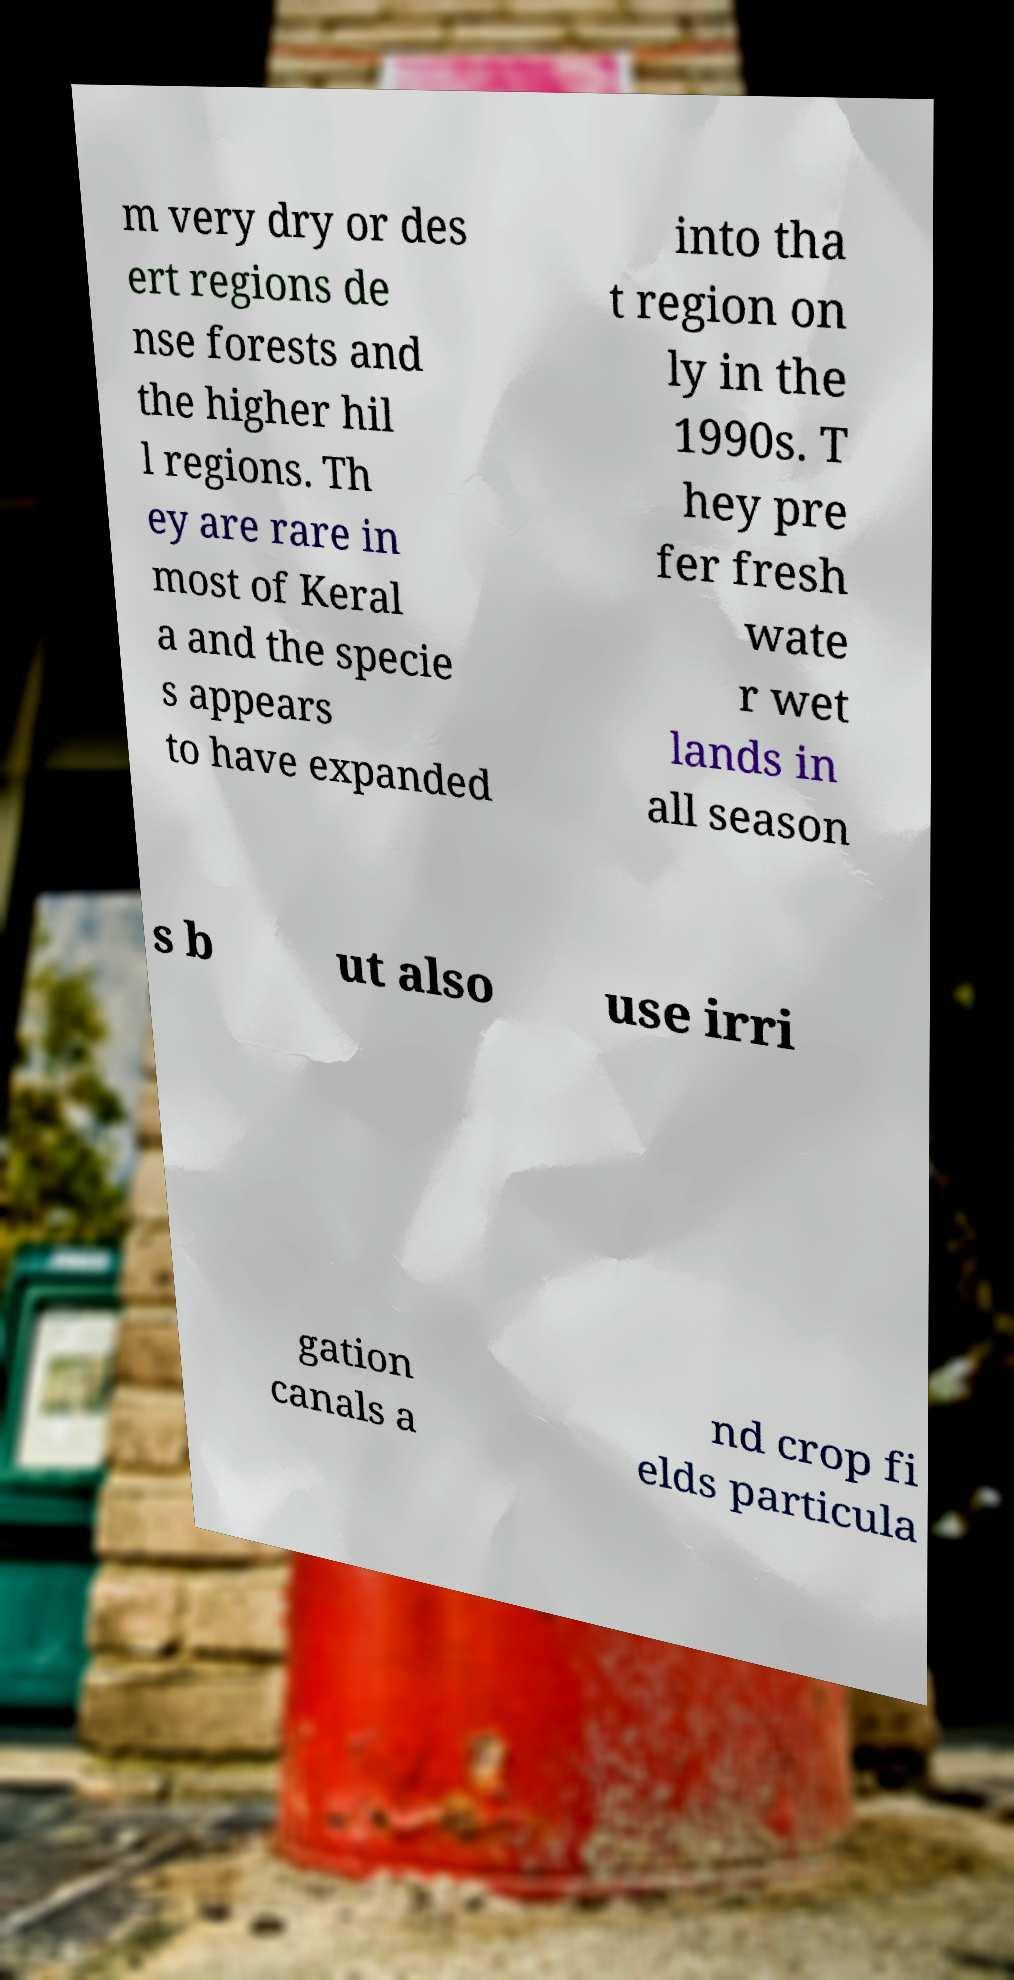Could you assist in decoding the text presented in this image and type it out clearly? m very dry or des ert regions de nse forests and the higher hil l regions. Th ey are rare in most of Keral a and the specie s appears to have expanded into tha t region on ly in the 1990s. T hey pre fer fresh wate r wet lands in all season s b ut also use irri gation canals a nd crop fi elds particula 